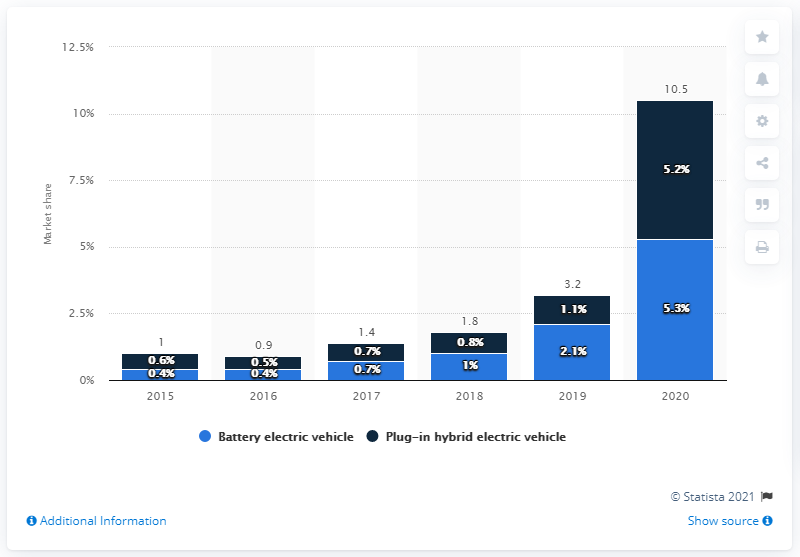Highlight a few significant elements in this photo. In 2020, the share of plug-in hybrid electric vehicle registrations was 5.2%. In 2020, the highest percentage of new passenger car registrations with all-electric propulsion in the European Union was 5.3%. 